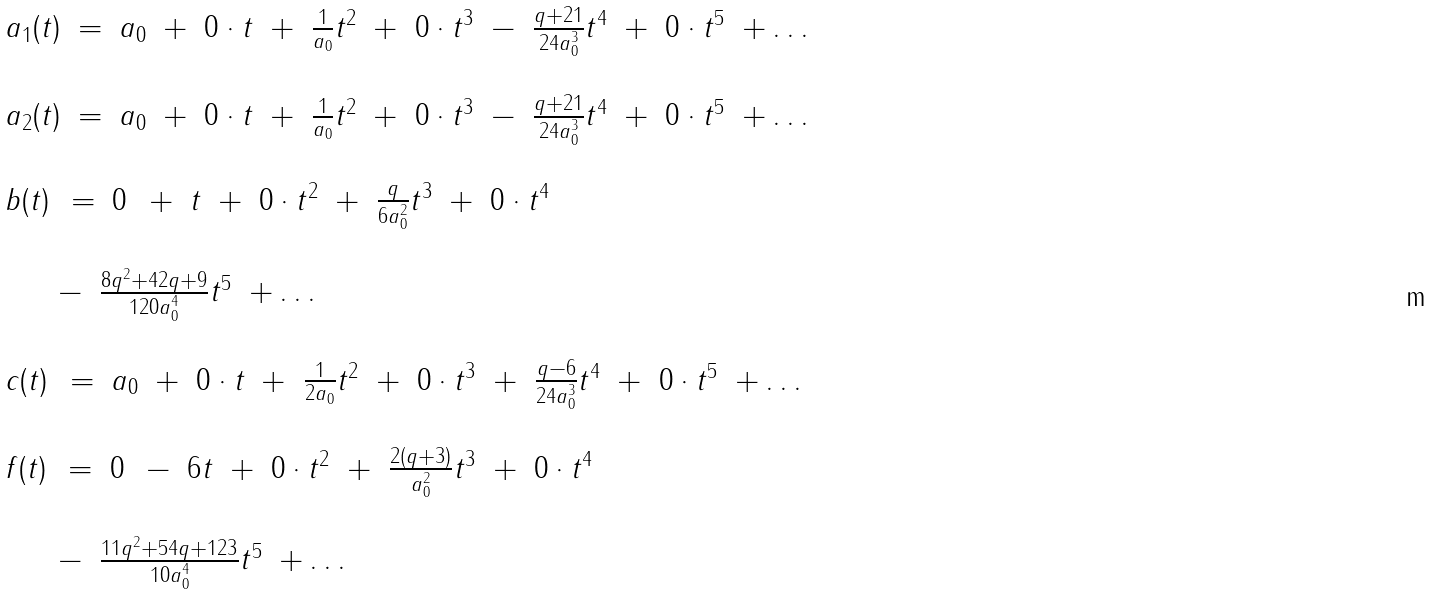<formula> <loc_0><loc_0><loc_500><loc_500>\begin{array} { l } \begin{array} { r c l r r r r r r r r r r l } a _ { 1 } ( t ) & = & a _ { 0 } & + & 0 \cdot t & + & \frac { 1 } { a _ { 0 } } t ^ { 2 } & + & 0 \cdot t ^ { 3 } & - & \frac { q + 2 1 } { 2 4 a _ { 0 } ^ { 3 } } t ^ { 4 } & + & 0 \cdot t ^ { 5 } & + \dots \\ \end{array} \\ \\ \begin{array} { r c l r r r r r r r r r r l } a _ { 2 } ( t ) & = & a _ { 0 } & + & 0 \cdot t & + & \frac { 1 } { a _ { 0 } } t ^ { 2 } & + & 0 \cdot t ^ { 3 } & - & \frac { q + 2 1 } { 2 4 a _ { 0 } ^ { 3 } } t ^ { 4 } & + & 0 \cdot t ^ { 5 } & + \dots \\ \end{array} \\ \\ \begin{array} { r c l r r r r r r r l } b ( t ) \, & = & 0 \, & + & t & + & 0 \cdot t ^ { 2 } & + & \frac { q } { 6 a _ { 0 } ^ { 2 } } t ^ { 3 } & + & 0 \cdot t ^ { 4 } \\ \end{array} \\ \\ \begin{array} { r r r l } \quad \, & - & \frac { 8 q ^ { 2 } + 4 2 q + 9 } { 1 2 0 a _ { 0 } ^ { 4 } } t ^ { 5 } & + \dots \\ \end{array} \\ \\ \begin{array} { r c l r r r r r r r r r r l } c ( t ) \, & = & a _ { 0 } & + & 0 \cdot t & + & \frac { 1 } { 2 a _ { 0 } } t ^ { 2 } & + & 0 \cdot t ^ { 3 } & + & \frac { q - 6 } { 2 4 a _ { 0 } ^ { 3 } } t ^ { 4 } & + & 0 \cdot t ^ { 5 } & + \dots \\ \end{array} \\ \\ \begin{array} { r c l r r r r r r r l } f ( t ) \, & = & 0 \, & - & 6 t & + & 0 \cdot t ^ { 2 } & + & \frac { 2 ( q + 3 ) } { a _ { 0 } ^ { 2 } } t ^ { 3 } & + & 0 \cdot t ^ { 4 } \\ \end{array} \\ \\ \begin{array} { r r r l } \quad \, & - & \frac { 1 1 q ^ { 2 } + 5 4 q + 1 2 3 } { 1 0 a _ { 0 } ^ { 4 } } t ^ { 5 } & + \dots \\ \end{array} \end{array}</formula> 